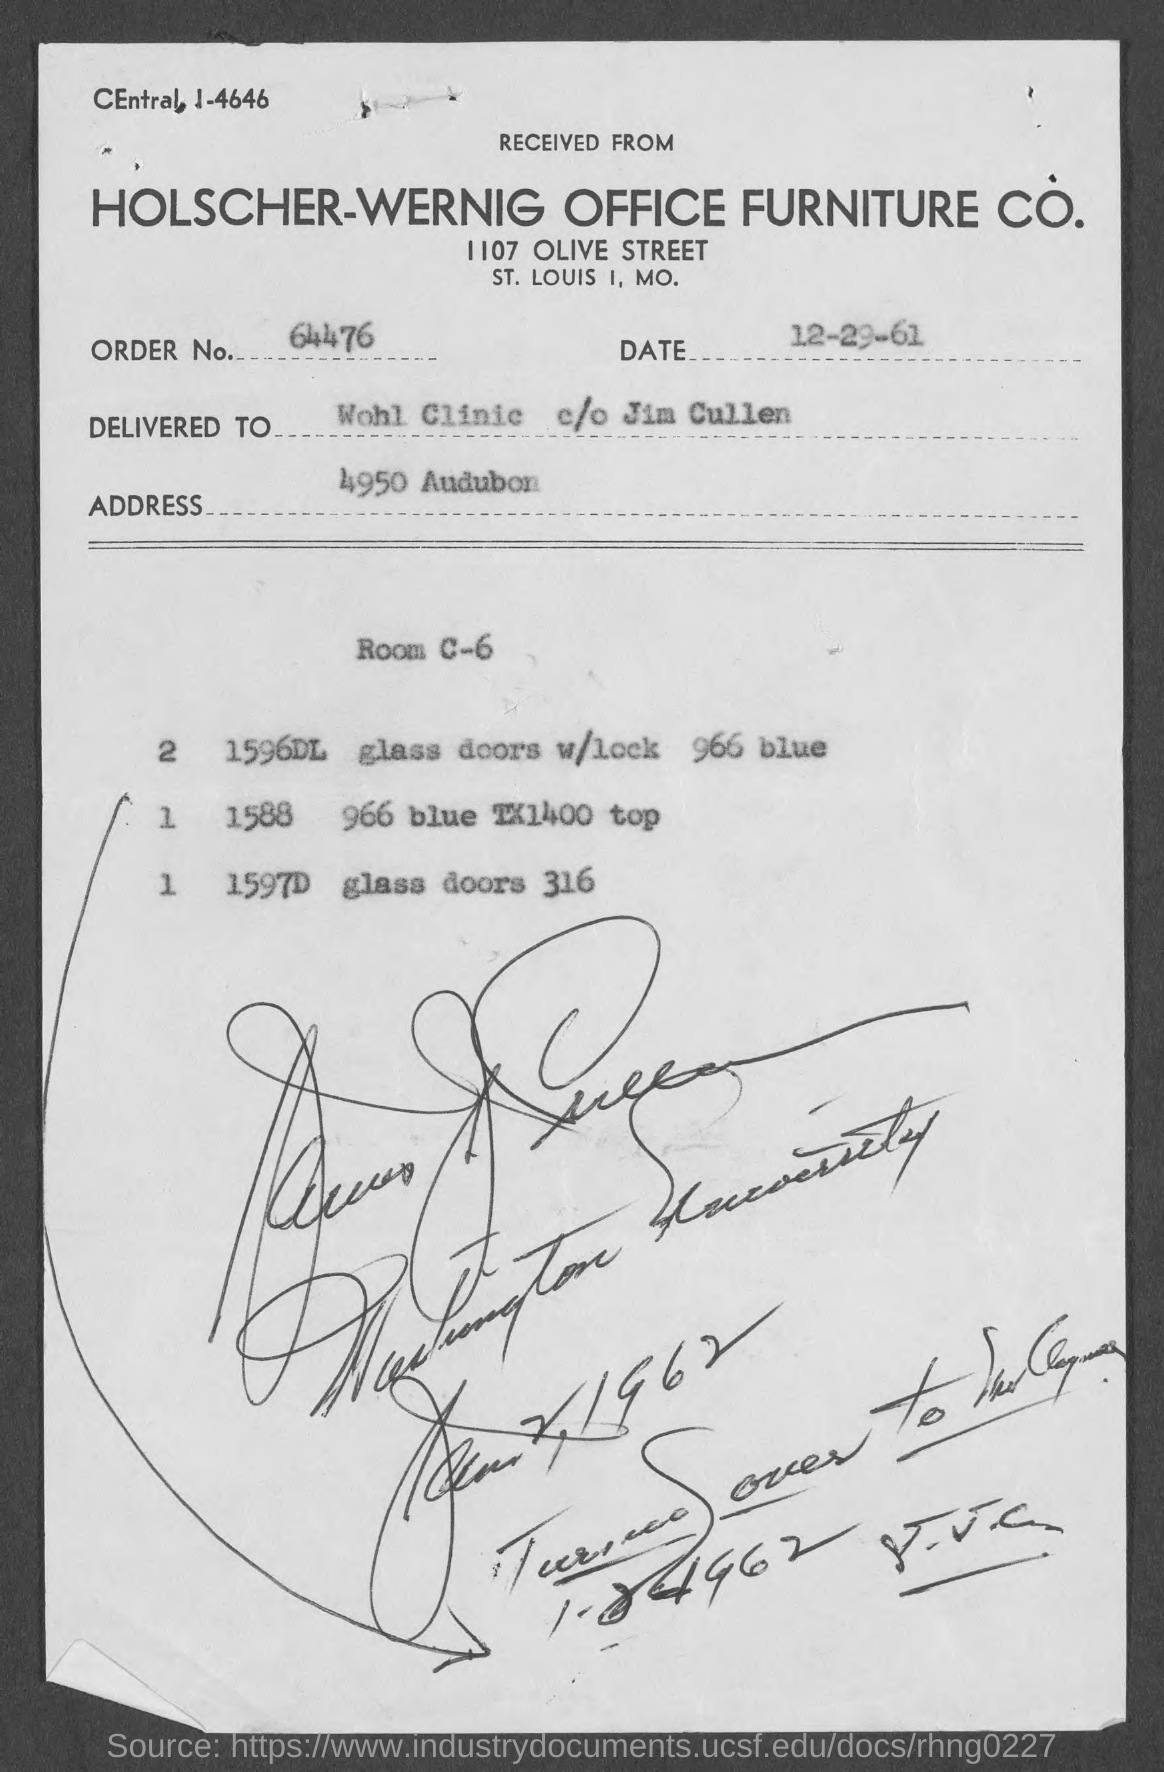What is the order no.?
Offer a terse response. 64476. What is the address ?
Give a very brief answer. 4950 audubon. What is the date mentioned in document?
Make the answer very short. 12-29-61. 